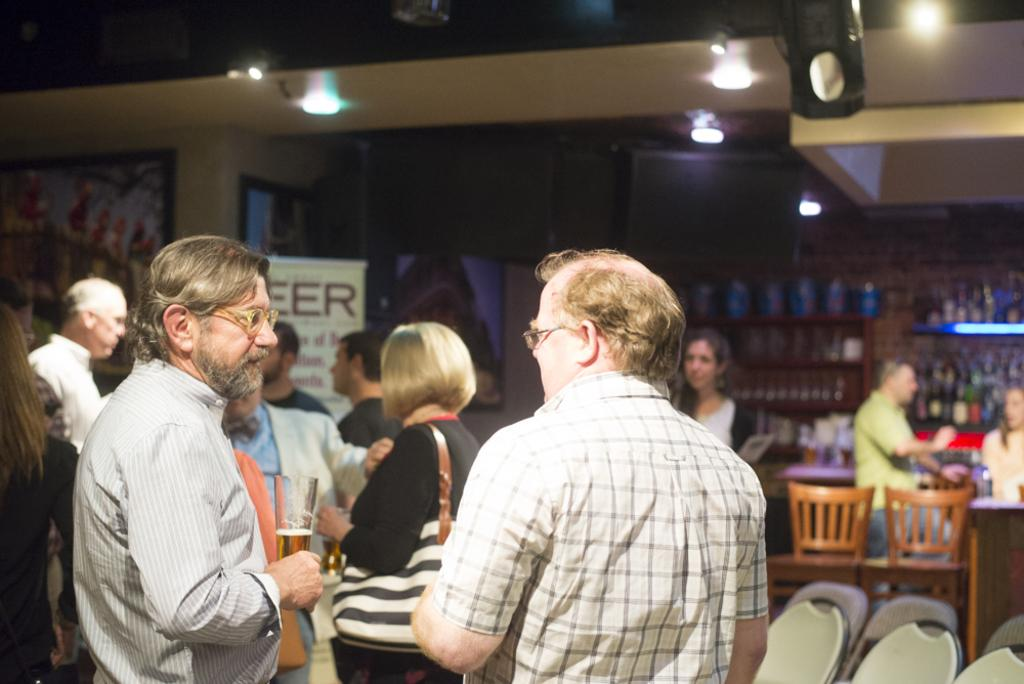What is happening in the room in the image? There are people standing in the room, some of whom are men and some are women. Can you describe the furniture in the background? There are two chairs in the background. What is the man near the table doing? There is a man standing near a table. What is the setting of the image? There is a wall in the room. What type of wristwatch is the woman wearing in the image? There is no woman wearing a wristwatch in the image. Is there a church visible in the image? No, there is no church present in the image. 